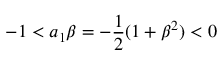Convert formula to latex. <formula><loc_0><loc_0><loc_500><loc_500>- 1 < a _ { 1 } \beta = - \frac { 1 } { 2 } ( 1 + \beta ^ { 2 } ) < 0</formula> 